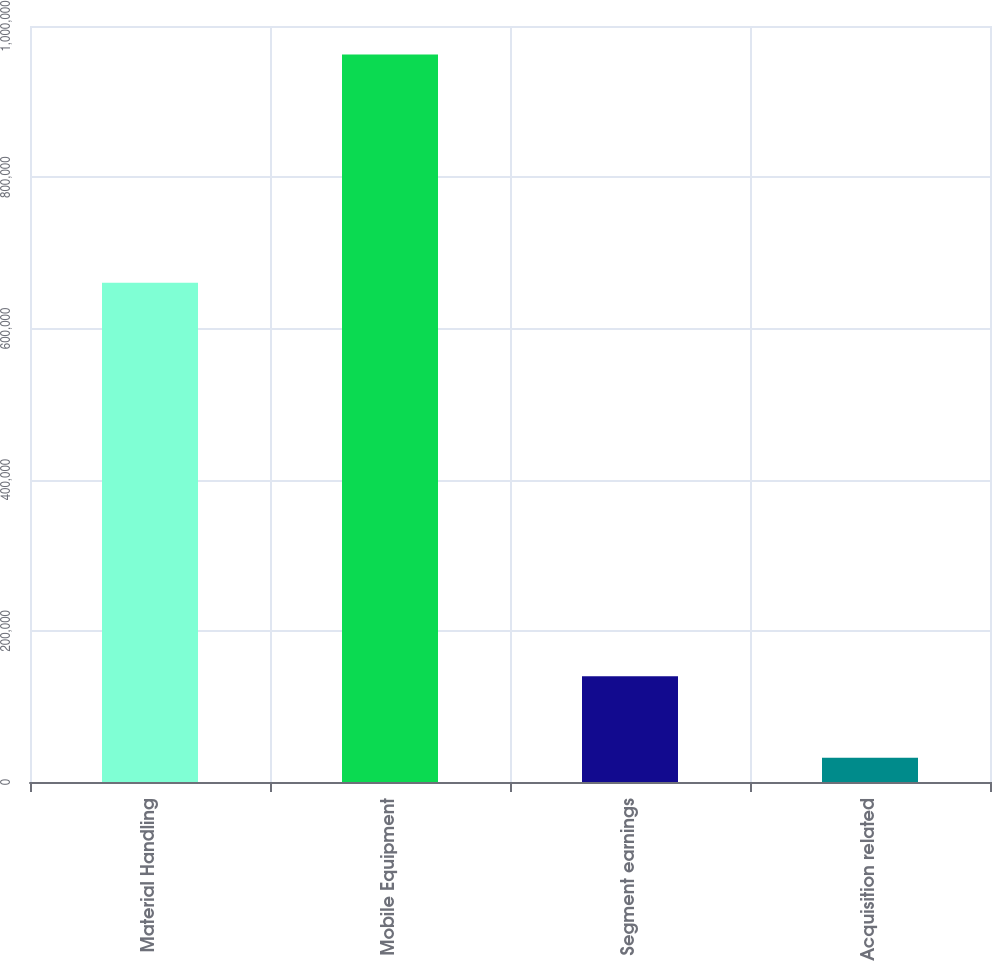Convert chart to OTSL. <chart><loc_0><loc_0><loc_500><loc_500><bar_chart><fcel>Material Handling<fcel>Mobile Equipment<fcel>Segment earnings<fcel>Acquisition related<nl><fcel>660353<fcel>962177<fcel>139757<fcel>32048<nl></chart> 